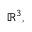<formula> <loc_0><loc_0><loc_500><loc_500>\mathbb { R } ^ { 3 } ,</formula> 